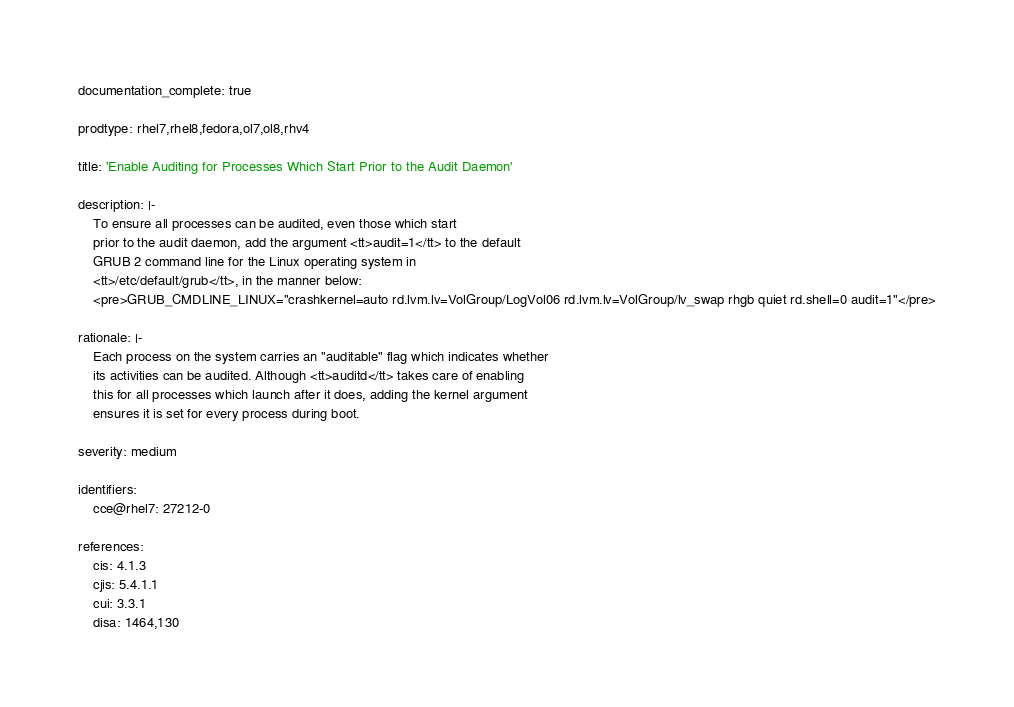<code> <loc_0><loc_0><loc_500><loc_500><_YAML_>documentation_complete: true

prodtype: rhel7,rhel8,fedora,ol7,ol8,rhv4

title: 'Enable Auditing for Processes Which Start Prior to the Audit Daemon'

description: |-
    To ensure all processes can be audited, even those which start
    prior to the audit daemon, add the argument <tt>audit=1</tt> to the default
    GRUB 2 command line for the Linux operating system in
    <tt>/etc/default/grub</tt>, in the manner below:
    <pre>GRUB_CMDLINE_LINUX="crashkernel=auto rd.lvm.lv=VolGroup/LogVol06 rd.lvm.lv=VolGroup/lv_swap rhgb quiet rd.shell=0 audit=1"</pre>

rationale: |-
    Each process on the system carries an "auditable" flag which indicates whether
    its activities can be audited. Although <tt>auditd</tt> takes care of enabling
    this for all processes which launch after it does, adding the kernel argument
    ensures it is set for every process during boot.

severity: medium

identifiers:
    cce@rhel7: 27212-0

references:
    cis: 4.1.3
    cjis: 5.4.1.1
    cui: 3.3.1
    disa: 1464,130</code> 